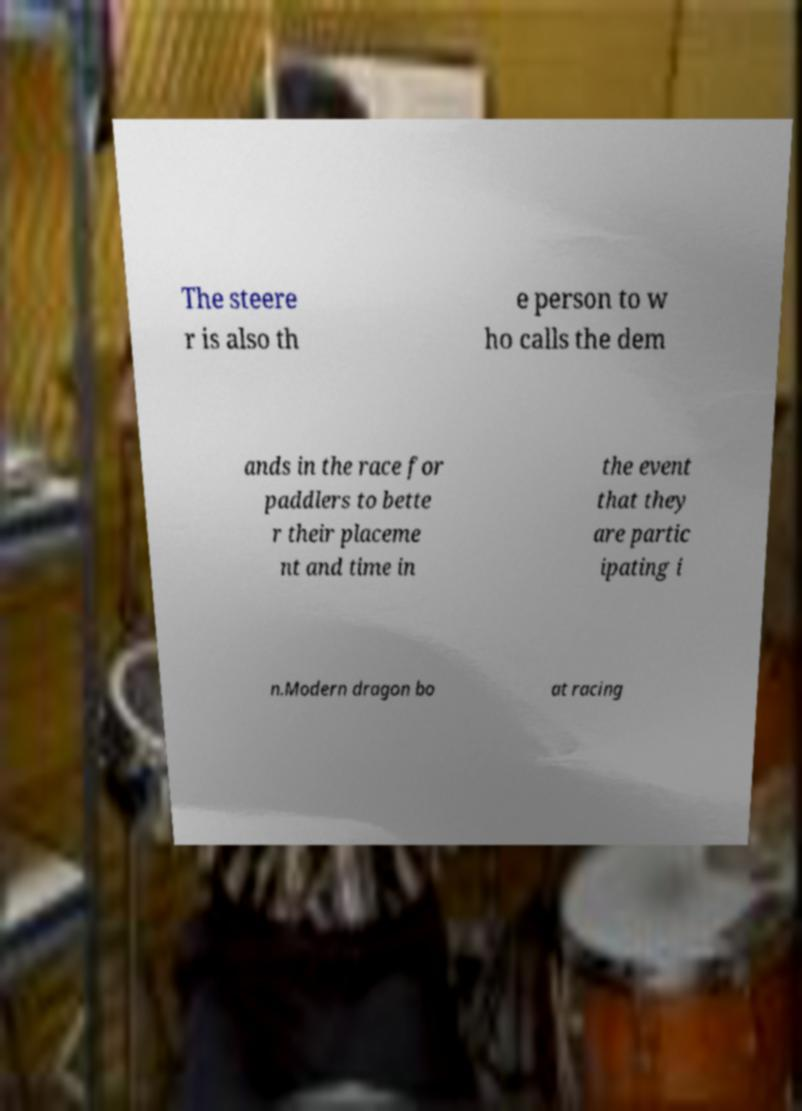What messages or text are displayed in this image? I need them in a readable, typed format. The steere r is also th e person to w ho calls the dem ands in the race for paddlers to bette r their placeme nt and time in the event that they are partic ipating i n.Modern dragon bo at racing 